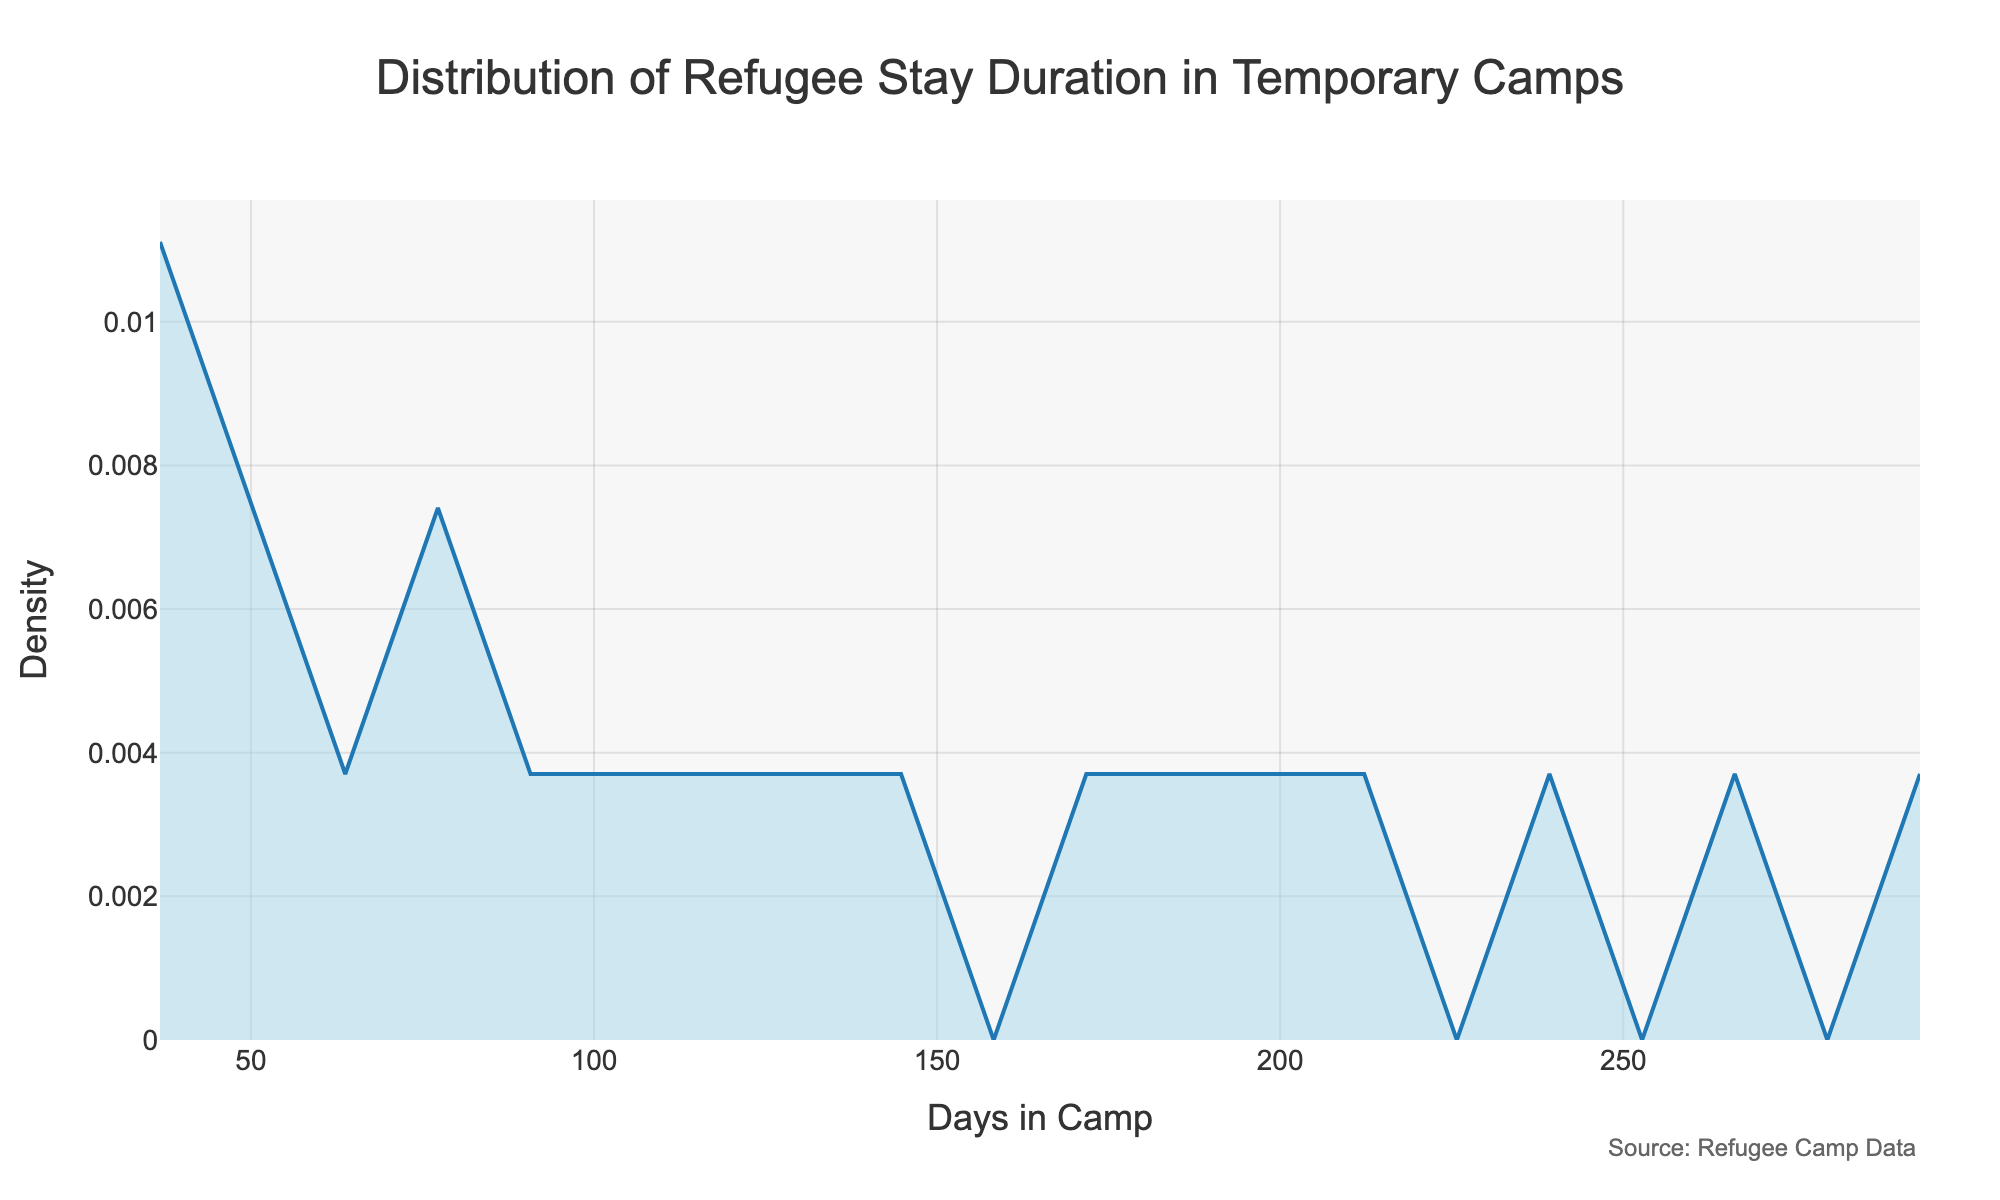How many peaks are visible in the density plot? By looking at the density curve, we observe that there are points where the curve reaches local maximums. Peaks in a density plot indicate modes or common values in the distribution.
Answer: 1 What does the title of the plot say? The title is prominently displayed at the top of the plot, indicating the main subject of the figure.
Answer: Distribution of Refugee Stay Duration in Temporary Camps What is the density value at the peak? By examining the height of the peak in the density plot, we can determine its corresponding density value on the y-axis.
Answer: Closest to 0.007 Which country has the shortest average stay in the camps shown in the plot? By referring to the data provided and locating the lowest point on the x-axis corresponding to a length of stay, we find the country with the minimum duration.
Answer: Germany What is the range of days covered in the x-axis? The x-axis represents the number of days in camp, and by examining the axis, we can determine the range it covers.
Answer: Approximately 0 to 300 days Is the distribution of stay durations more skewed towards shorter or longer stays? By observing the shape and spread of the density plot, we can categorize the skewness. If the plot leans more to the right, it indicates a longer tail, suggesting skewness towards longer stays.
Answer: Longer stays What is the most common length of stay in the camps shown in the plot? To answer this, we look for the value on the x-axis where the peak of the density curve occurs.
Answer: Approximately 100 days Are there more countries with stays below 100 days or above 200 days in the dataset? By counting the number of data points below 100 and above 200 in the provided data, we can determine the answer. Below 100 days: Greece, Jordan, Italy, Germany, France, Sweden, Spain, Netherlands, Mexico (9 countries). Above 200 days: Uganda, Kenya, Ethiopia, Bangladesh, Pakistan (5 countries).
Answer: Below 100 days What is the difference between the highest and lowest lengths of stay in the camps according to the data? The highest value in the dataset is Kenya with 300 days and the lowest is Germany with 30 days. By subtracting these two values, we get the difference.
Answer: 270 days How many countries have a length of stay in camps below the peak stay period shown in the density plot? The peak stay period is around 100 days. Counting the countries with days in camp less than 100 days gives Germany, Greece, Italy, Jordan, Netherlands, Spain, Sweden, France, Mexico.
Answer: 9 countries 